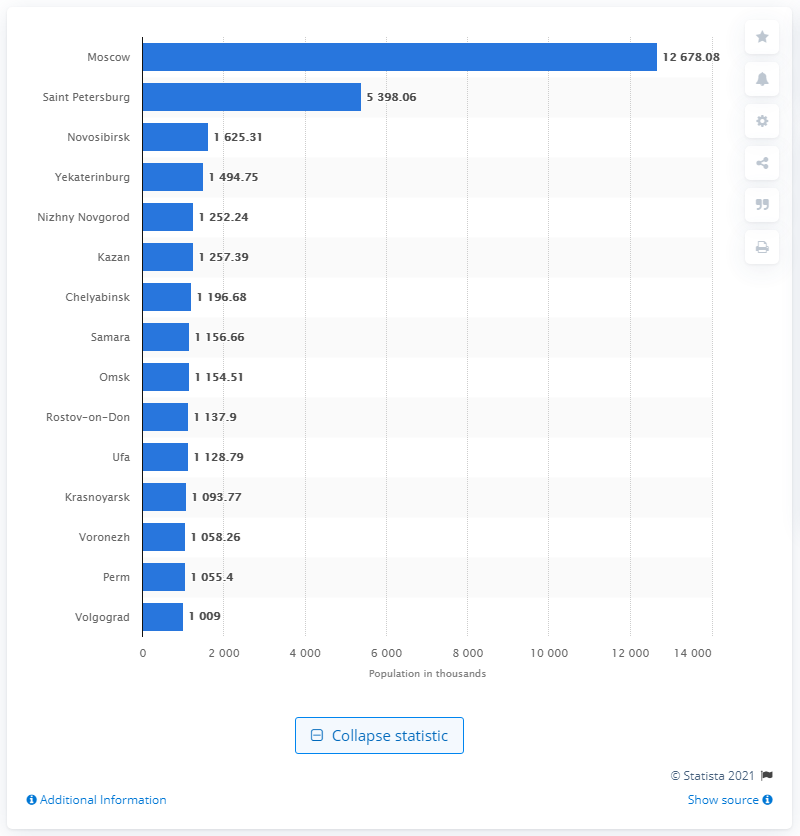Specify some key components in this picture. The second most populous city in Russia is Saint Petersburg. Novosibirsk is the third largest city in Russia, with a population of... 